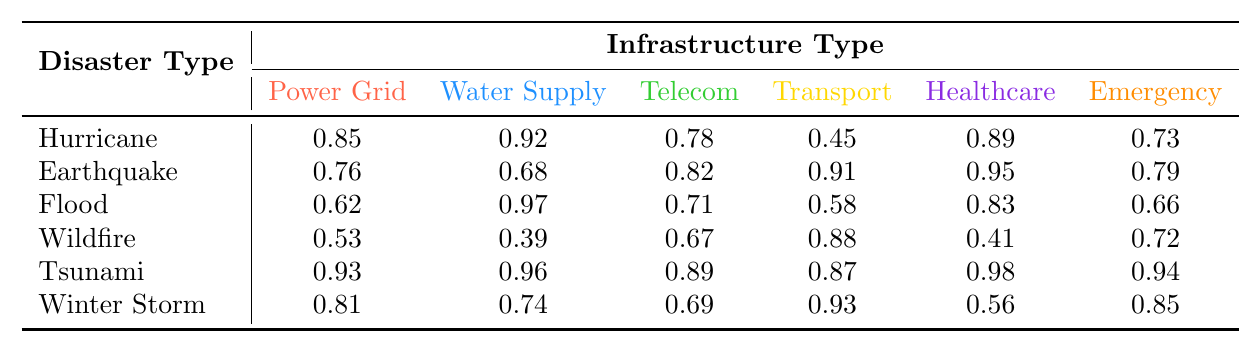What is the failure rate of the Power Grid during a Hurricane? The table shows the failure rate for the Power Grid during a Hurricane is 0.85.
Answer: 0.85 Which infrastructure type has the highest failure rate during a Tsunami? By looking at the Tsunami row, the healthcare facilities have the highest failure rate of 0.98.
Answer: Healthcare Facilities What is the failure rate of Telecommunications during a Flood? The table indicates that the failure rate of Telecommunications during a Flood is 0.71.
Answer: 0.71 Which disaster type has the lowest failure rate for Emergency Services? The Wildfire disaster type has the lowest failure rate for Emergency Services at 0.72.
Answer: Wildfire What is the average failure rate of Water Supply across all disasters? To find the average, sum the Water Supply failure rates (0.92 + 0.68 + 0.97 + 0.39 + 0.96 + 0.74 = 4.66) and divide by 6, resulting in an average of 0.7767, rounded to 0.78.
Answer: 0.78 Does the Power Grid have a higher failure rate than Telecommunications during a Severe Winter Storm? The failure rate for Power Grid is 0.81 and for Telecommunications is 0.69, thus the Power Grid has a higher failure rate.
Answer: Yes Which disaster caused the highest average failure rate across all infrastructure types? To calculate the average for each disaster, sum up the failure rates and divide by 6: Hurricane (0.85 + 0.92 + 0.78 + 0.45 + 0.89 + 0.73 = 4.62), Earthquake (0.76 + 0.68 + 0.82 + 0.91 + 0.95 + 0.79 = 4.91), Flood (0.62 + 0.97 + 0.71 + 0.58 + 0.83 + 0.66 = 4.37), Wildfire (0.53 + 0.39 + 0.67 + 0.88 + 0.41 + 0.72 = 3.60), Tsunami (0.93 + 0.96 + 0.89 + 0.87 + 0.98 + 0.94 = 5.57), Winter Storm (0.81 + 0.74 + 0.69 + 0.93 + 0.56 + 0.85 = 4.58). The Tsunami has the highest average failure rate at 5.57.
Answer: Tsunami How many infrastructure types have a failure rate of over 0.8 during an Earthquake? The infrastructure types exceeding 0.8 are Power Grid (0.76), Telecommunications (0.82), and Healthcare Facilities (0.95), totaling 4 types.
Answer: 4 What is the recovery time for Telecommunications during a Flood? The recovery time is listed as 48 hours in the table corresponding to Telecommunications during a Flood.
Answer: 48 hours Is the failure rate of Water Supply during an Earthquake greater than or equal to 0.7? The failure rate shown is 0.68, which is less than 0.7.
Answer: No 